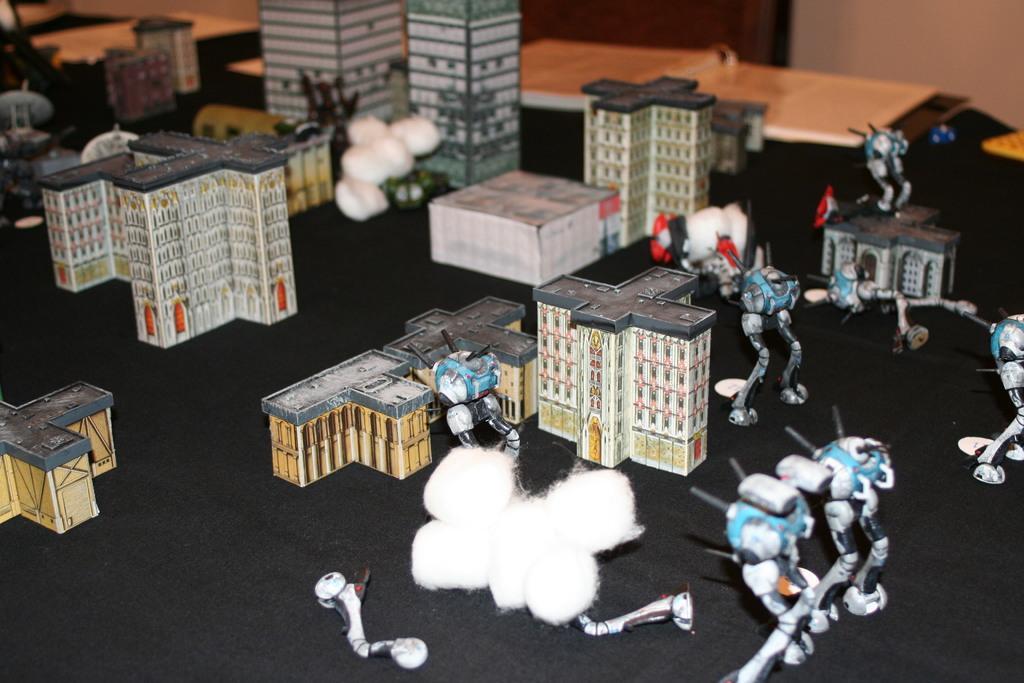How would you summarize this image in a sentence or two? In this image there are some toys and there are buildings, and in the background there is wall, door. At the bottom there might be a cloth. 